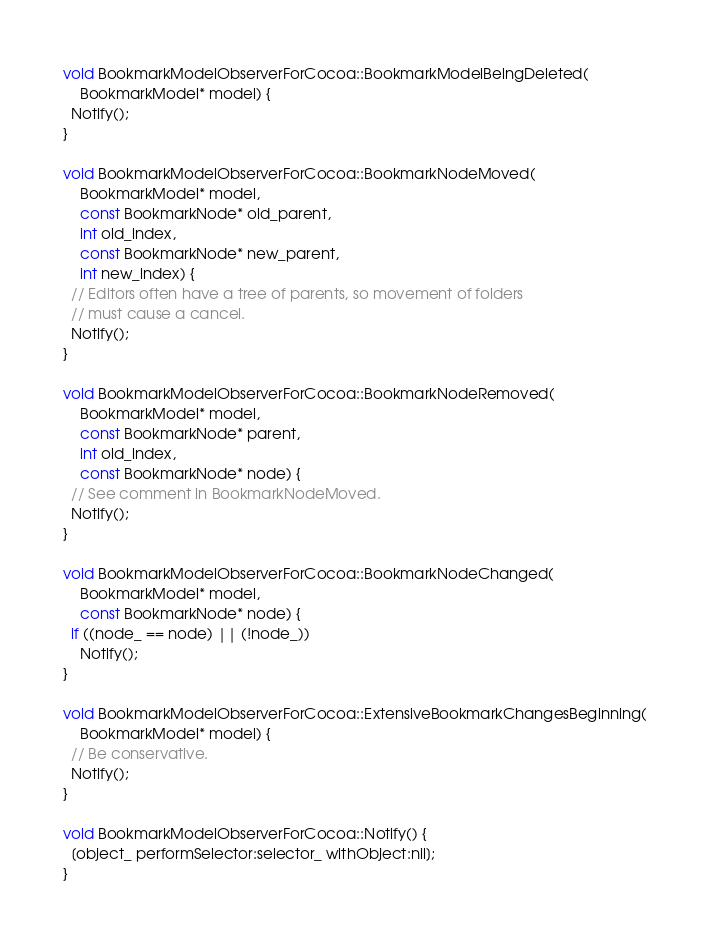Convert code to text. <code><loc_0><loc_0><loc_500><loc_500><_ObjectiveC_>void BookmarkModelObserverForCocoa::BookmarkModelBeingDeleted(
    BookmarkModel* model) {
  Notify();
}

void BookmarkModelObserverForCocoa::BookmarkNodeMoved(
    BookmarkModel* model,
    const BookmarkNode* old_parent,
    int old_index,
    const BookmarkNode* new_parent,
    int new_index) {
  // Editors often have a tree of parents, so movement of folders
  // must cause a cancel.
  Notify();
}

void BookmarkModelObserverForCocoa::BookmarkNodeRemoved(
    BookmarkModel* model,
    const BookmarkNode* parent,
    int old_index,
    const BookmarkNode* node) {
  // See comment in BookmarkNodeMoved.
  Notify();
}

void BookmarkModelObserverForCocoa::BookmarkNodeChanged(
    BookmarkModel* model,
    const BookmarkNode* node) {
  if ((node_ == node) || (!node_))
    Notify();
}

void BookmarkModelObserverForCocoa::ExtensiveBookmarkChangesBeginning(
    BookmarkModel* model) {
  // Be conservative.
  Notify();
}

void BookmarkModelObserverForCocoa::Notify() {
  [object_ performSelector:selector_ withObject:nil];
}
</code> 